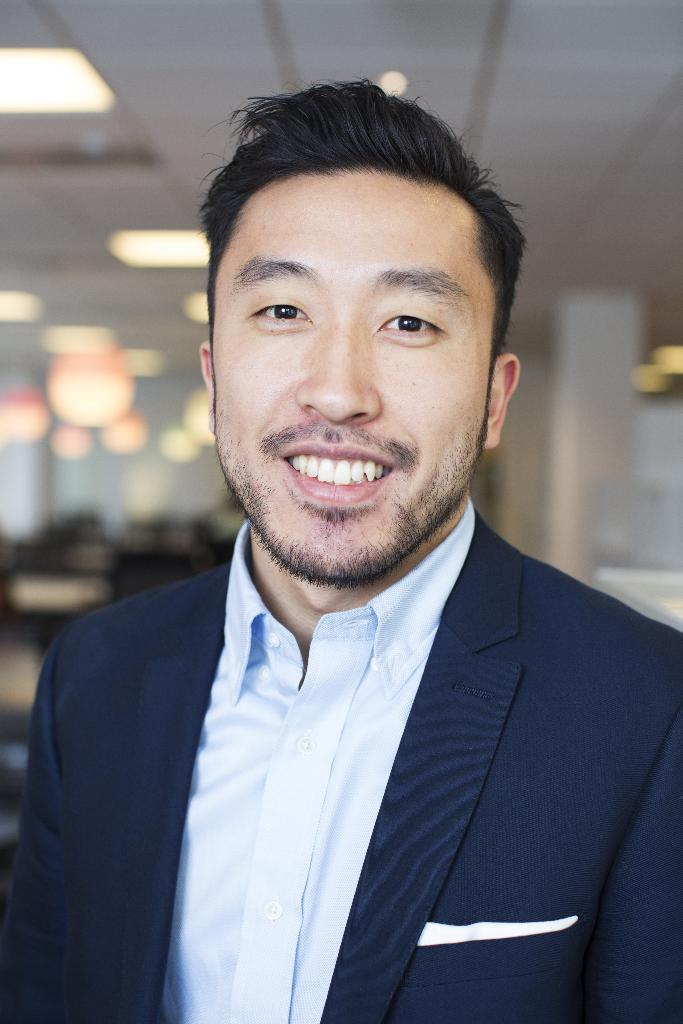What is the main subject of the image? The main subject of the image is a man. What is the man wearing in the image? The man is wearing clothes in the image. What is the man's facial expression in the image? The man is smiling in the image. Can you describe the background of the image? The background of the image is blurred. What type of wine is the man holding in the image? There is no wine present in the image; the man is not holding any wine. What language is the man speaking in the image? There is no indication of the man speaking in the image, so it cannot be determined what language he might be using. 